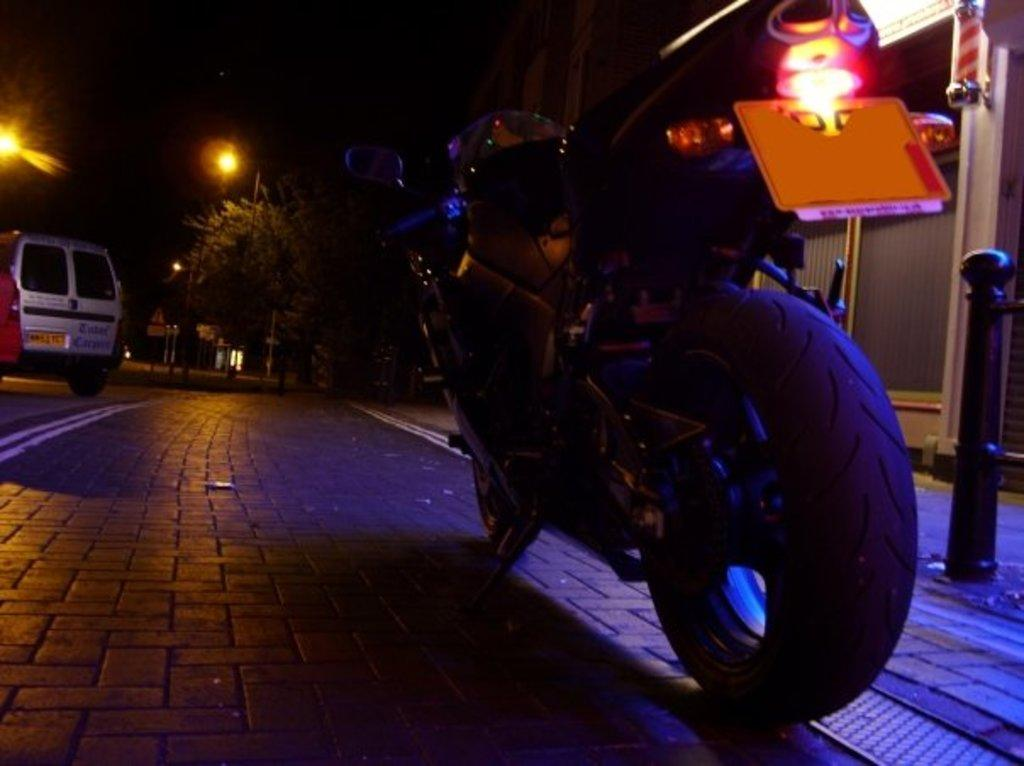What is the main object in the foreground of the image? There is a bike in the foreground of the image. What can be seen in the background of the image? There are vehicles and lamps in the background of the image. What type of vegetation is visible in the background of the image? There are trees in the background of the image. What type of soup is being served for breakfast in the image? There is no soup or breakfast depicted in the image; it features a bike in the foreground and various objects in the background. What type of suit is the person wearing in the image? There is no person wearing a suit in the image. 